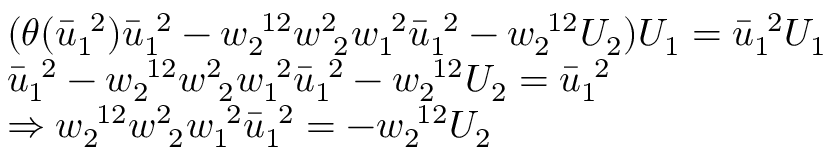<formula> <loc_0><loc_0><loc_500><loc_500>\begin{array} { r l } & { ( \theta ( \bar { u } _ { 1 \ } ^ { \ 2 } ) \bar { u } _ { 1 \ } ^ { \ 2 } - w _ { 2 \ } ^ { \ 1 2 } w _ { \ 2 } ^ { 2 \ } w _ { 1 \ } ^ { \ 2 } \bar { u } _ { 1 \ } ^ { \ 2 } - w _ { 2 \ } ^ { \ 1 2 } U _ { 2 } ) U _ { 1 } = \bar { u } _ { 1 \ } ^ { \ 2 } U _ { 1 } } \\ & { \bar { u } _ { 1 \ } ^ { \ 2 } - w _ { 2 \ } ^ { \ 1 2 } w _ { \ 2 } ^ { 2 \ } w _ { 1 \ } ^ { \ 2 } \bar { u } _ { 1 \ } ^ { \ 2 } - w _ { 2 \ } ^ { \ 1 2 } U _ { 2 } = \bar { u } _ { 1 \ } ^ { \ 2 } } \\ & { \Rightarrow w _ { 2 \ } ^ { \ 1 2 } w _ { \ 2 } ^ { 2 \ } w _ { 1 \ } ^ { \ 2 } \bar { u } _ { 1 \ } ^ { \ 2 } = - w _ { 2 \ } ^ { \ 1 2 } U _ { 2 } } \end{array}</formula> 